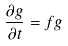Convert formula to latex. <formula><loc_0><loc_0><loc_500><loc_500>\frac { \partial g } { \partial t } = f g</formula> 